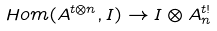Convert formula to latex. <formula><loc_0><loc_0><loc_500><loc_500>H o m ( A ^ { t \otimes n } , I ) \rightarrow I \otimes A ^ { t ! } _ { n }</formula> 